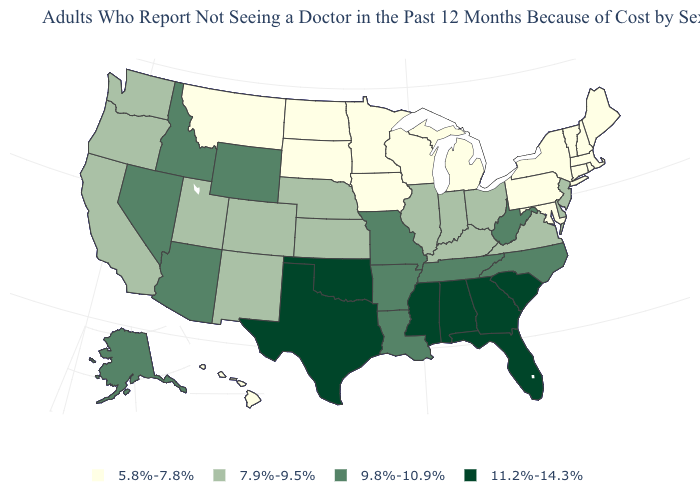What is the value of Virginia?
Give a very brief answer. 7.9%-9.5%. Name the states that have a value in the range 9.8%-10.9%?
Answer briefly. Alaska, Arizona, Arkansas, Idaho, Louisiana, Missouri, Nevada, North Carolina, Tennessee, West Virginia, Wyoming. Among the states that border Massachusetts , which have the highest value?
Short answer required. Connecticut, New Hampshire, New York, Rhode Island, Vermont. Which states have the lowest value in the MidWest?
Concise answer only. Iowa, Michigan, Minnesota, North Dakota, South Dakota, Wisconsin. Among the states that border Wyoming , which have the highest value?
Concise answer only. Idaho. What is the lowest value in the USA?
Quick response, please. 5.8%-7.8%. Name the states that have a value in the range 11.2%-14.3%?
Short answer required. Alabama, Florida, Georgia, Mississippi, Oklahoma, South Carolina, Texas. What is the lowest value in the MidWest?
Answer briefly. 5.8%-7.8%. Does Florida have the highest value in the USA?
Short answer required. Yes. Among the states that border Texas , which have the highest value?
Concise answer only. Oklahoma. Name the states that have a value in the range 7.9%-9.5%?
Be succinct. California, Colorado, Delaware, Illinois, Indiana, Kansas, Kentucky, Nebraska, New Jersey, New Mexico, Ohio, Oregon, Utah, Virginia, Washington. What is the value of New Jersey?
Keep it brief. 7.9%-9.5%. Does the map have missing data?
Keep it brief. No. What is the highest value in states that border California?
Answer briefly. 9.8%-10.9%. Does Mississippi have the highest value in the USA?
Concise answer only. Yes. 